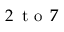Convert formula to latex. <formula><loc_0><loc_0><loc_500><loc_500>2 \, t o \, 7 \</formula> 